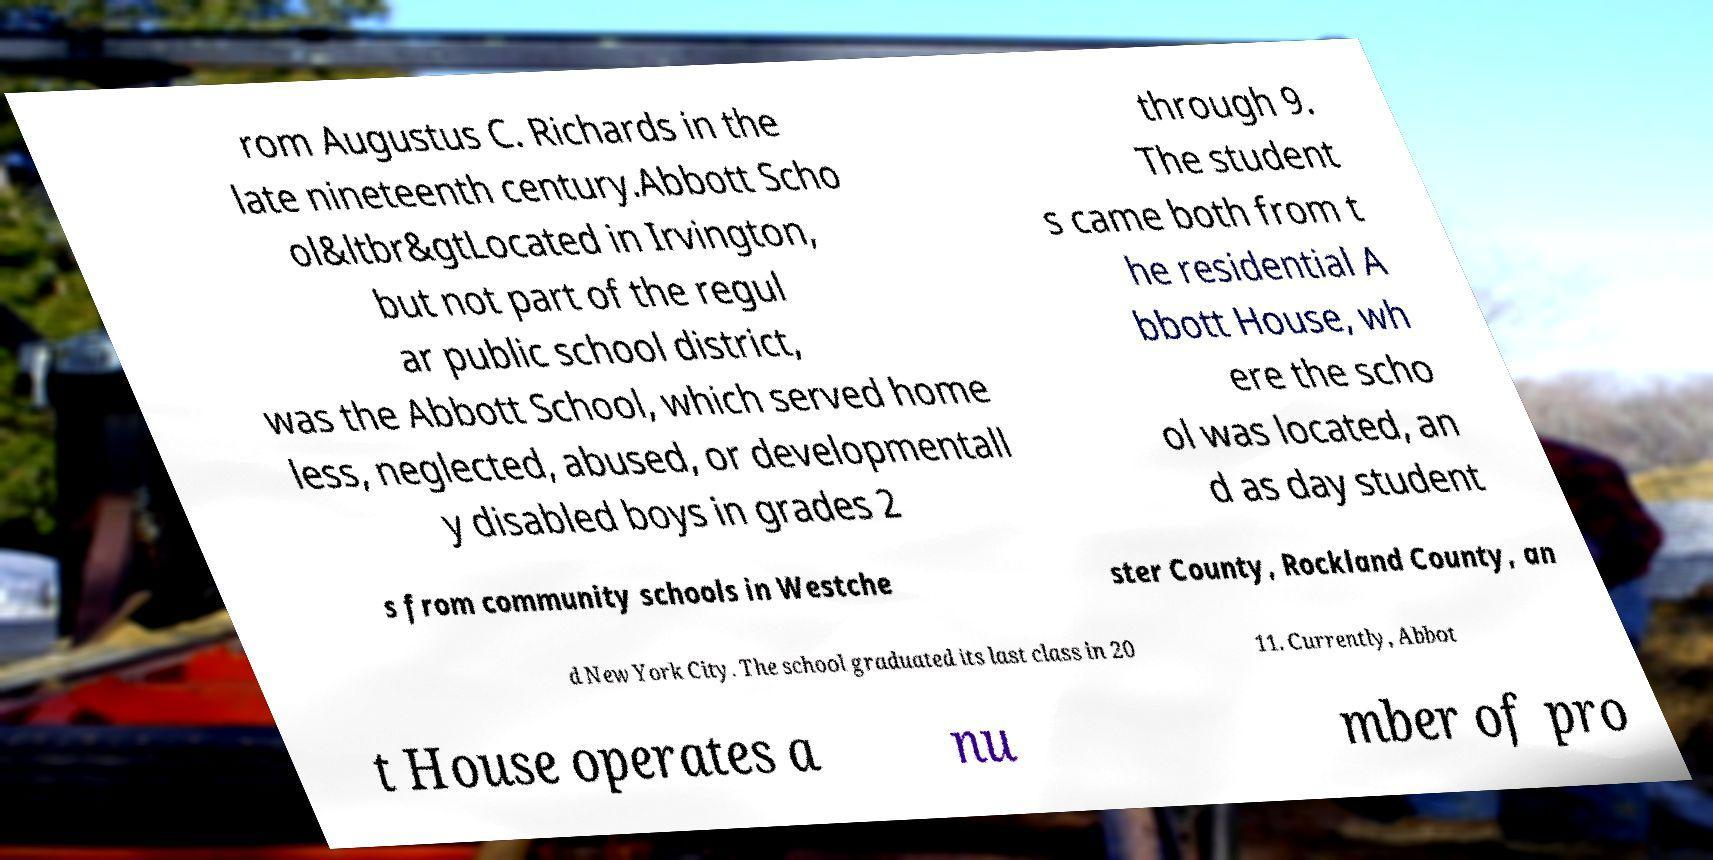Could you assist in decoding the text presented in this image and type it out clearly? rom Augustus C. Richards in the late nineteenth century.Abbott Scho ol&ltbr&gtLocated in Irvington, but not part of the regul ar public school district, was the Abbott School, which served home less, neglected, abused, or developmentall y disabled boys in grades 2 through 9. The student s came both from t he residential A bbott House, wh ere the scho ol was located, an d as day student s from community schools in Westche ster County, Rockland County, an d New York City. The school graduated its last class in 20 11. Currently, Abbot t House operates a nu mber of pro 